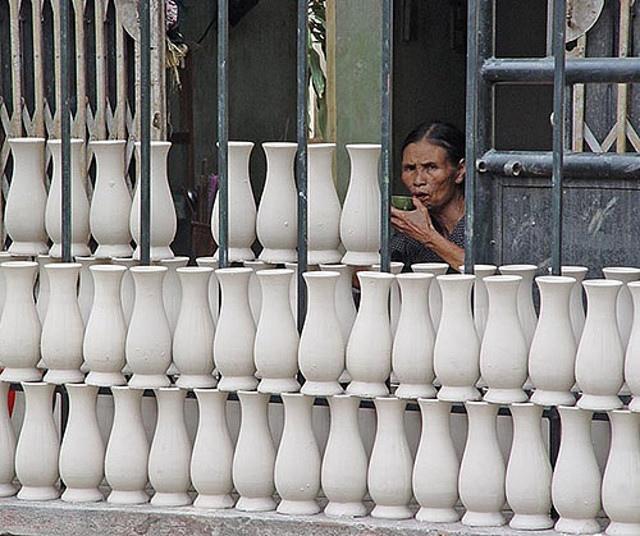What does she have in her hand?
Give a very brief answer. Cup. Is the woman smiling?
Give a very brief answer. No. What are the bottles used for?
Short answer required. Flowers. 